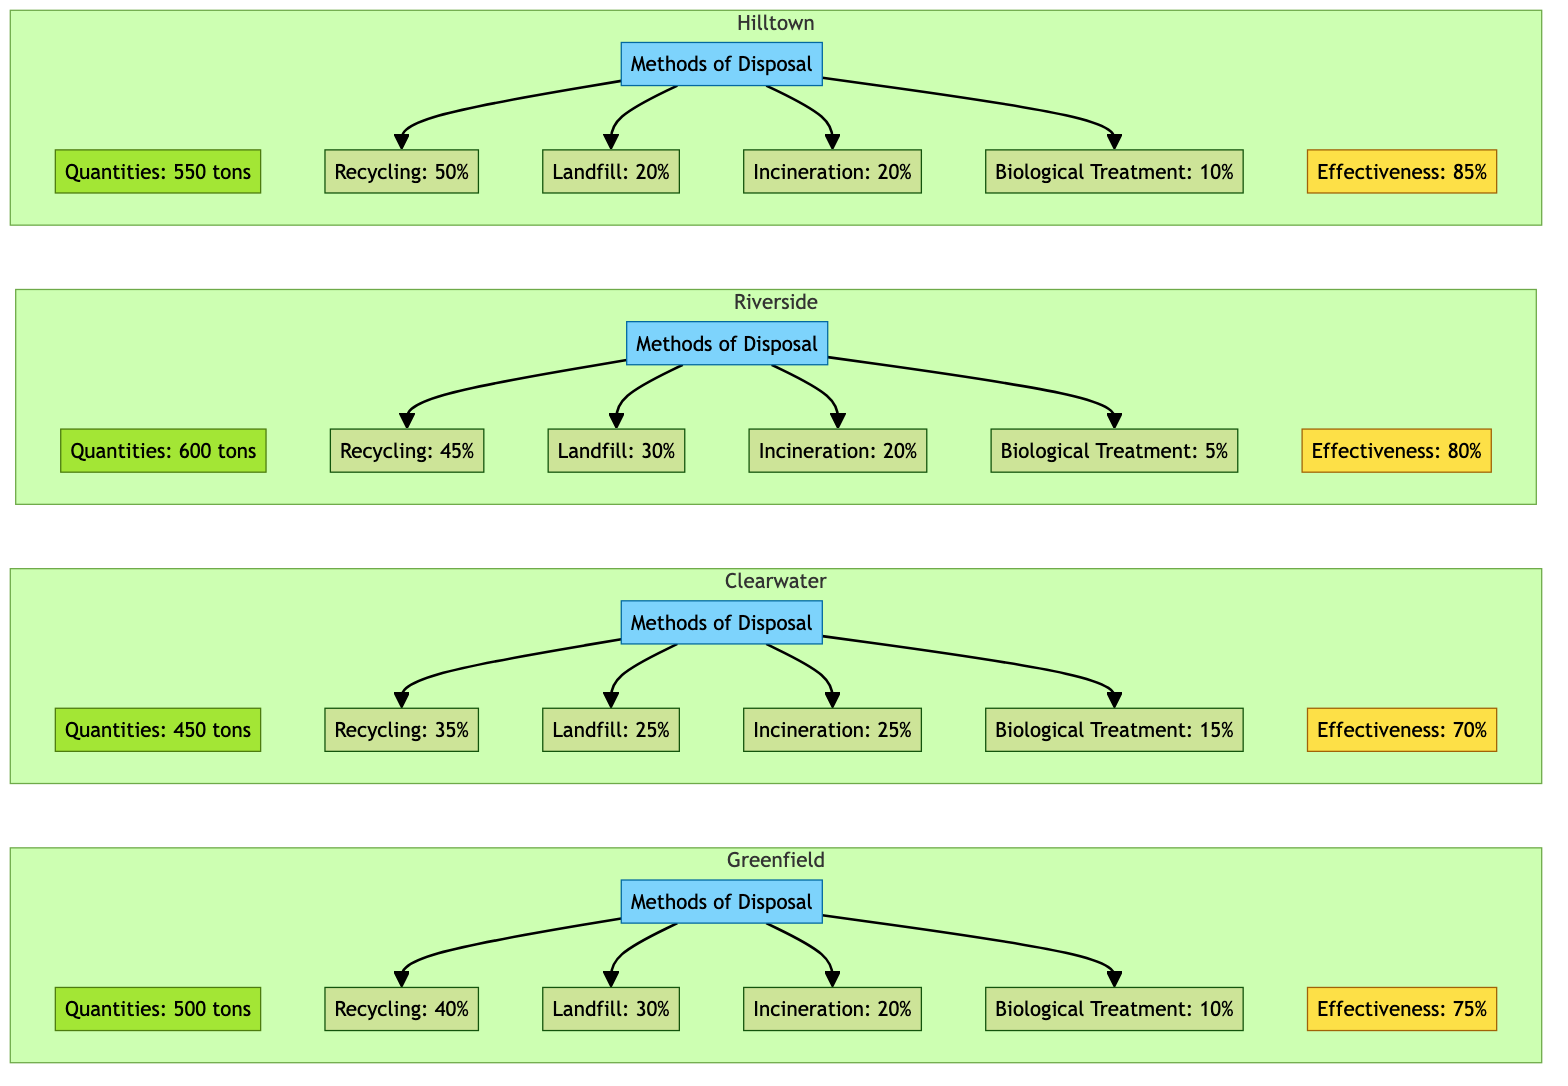What are the total quantities of chemical waste in Greenfield? The diagram shows that Greenfield has a quantity of chemical waste specified as 500 tons.
Answer: 500 tons What is the effectiveness of the chemical waste management in Riverside? According to the diagram, Riverside has an effectiveness rate of 80% for its chemical waste management practices.
Answer: 80% Which city has the highest recycling percentage? The diagram indicates that Hilltown has the highest recycling percentage at 50%, compared to other cities.
Answer: 50% How much chemical waste does Clearwater manage? The diagram shows that Clearwater manages a total quantity of 450 tons of chemical waste.
Answer: 450 tons What is the percentage of landfill disposal in Hilltown? The diagram shows that Hilltown disposes of 20% of its chemical waste in landfills.
Answer: 20% Which city's chemical waste management is the least effective? Analyzing the effectiveness rates in the diagram, Clearwater, with a rate of 70%, is the least effective among the listed cities.
Answer: Clearwater What is the total amount of chemical waste disposed of by incineration in Riverside? Riverside's methods of disposal indicate that 20% of its 600 tons of chemical waste is disposed of by incineration. This calculates to 120 tons.
Answer: 120 tons Which method of disposal is used the least in Riverside? The diagram indicates that Biological Treatment is the least used method in Riverside, with only 5% of the total waste being treated this way.
Answer: Biological Treatment How does the recycling percentage in Clearwater compare to Hilltown? Between Clearwater (35%) and Hilltown (50%), Hilltown has a higher recycling percentage than Clearwater, showing that it is more effective at recycling.
Answer: Hilltown has a higher recycling percentage 